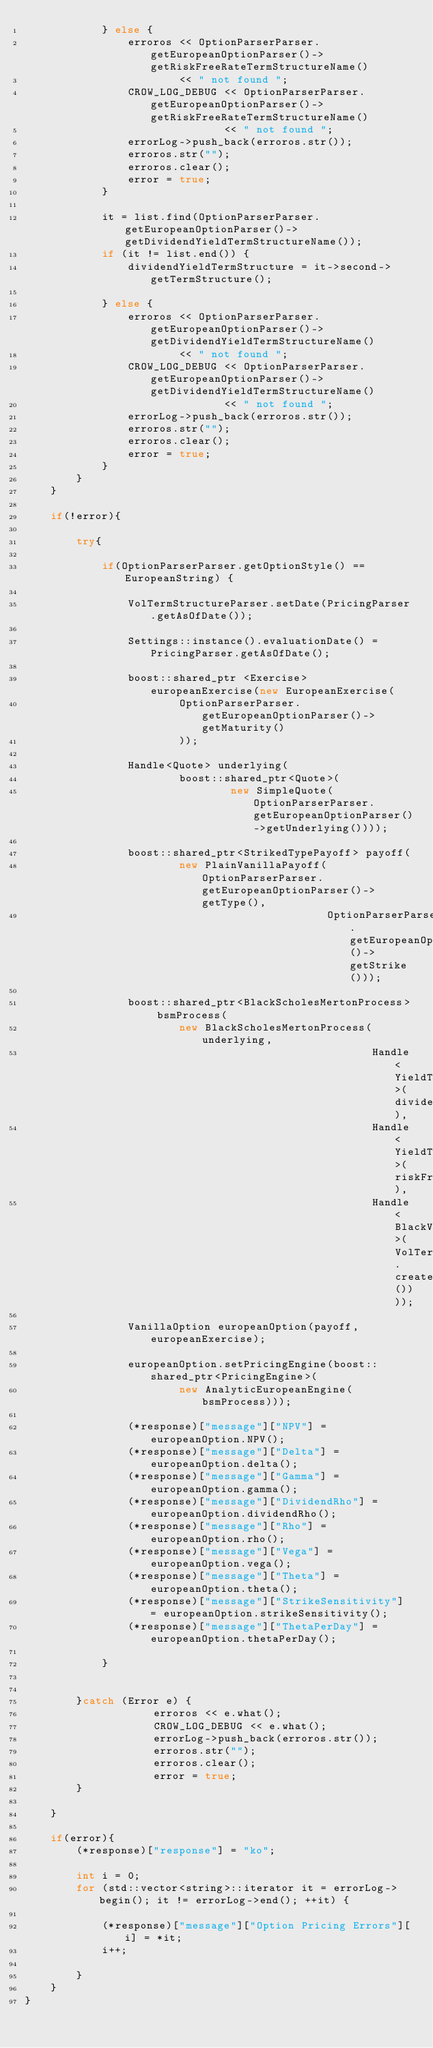Convert code to text. <code><loc_0><loc_0><loc_500><loc_500><_C++_>            } else {
                erroros << OptionParserParser.getEuropeanOptionParser()->getRiskFreeRateTermStructureName()
                        << " not found ";
                CROW_LOG_DEBUG << OptionParserParser.getEuropeanOptionParser()->getRiskFreeRateTermStructureName()
                               << " not found ";
                errorLog->push_back(erroros.str());
                erroros.str("");
                erroros.clear();
                error = true;
            }

            it = list.find(OptionParserParser.getEuropeanOptionParser()->getDividendYieldTermStructureName());
            if (it != list.end()) {
                dividendYieldTermStructure = it->second->getTermStructure();

            } else {
                erroros << OptionParserParser.getEuropeanOptionParser()->getDividendYieldTermStructureName()
                        << " not found ";
                CROW_LOG_DEBUG << OptionParserParser.getEuropeanOptionParser()->getDividendYieldTermStructureName()
                               << " not found ";
                errorLog->push_back(erroros.str());
                erroros.str("");
                erroros.clear();
                error = true;
            }
        }
    }

    if(!error){

        try{

            if(OptionParserParser.getOptionStyle() == EuropeanString) {

                VolTermStructureParser.setDate(PricingParser.getAsOfDate());

                Settings::instance().evaluationDate() = PricingParser.getAsOfDate();

                boost::shared_ptr <Exercise> europeanExercise(new EuropeanExercise(
                        OptionParserParser.getEuropeanOptionParser()->getMaturity()
                        ));

                Handle<Quote> underlying(
                        boost::shared_ptr<Quote>(
                                new SimpleQuote(OptionParserParser.getEuropeanOptionParser()->getUnderlying())));

                boost::shared_ptr<StrikedTypePayoff> payoff(
                        new PlainVanillaPayoff(OptionParserParser.getEuropeanOptionParser()->getType(),
                                               OptionParserParser.getEuropeanOptionParser()->getStrike()));

                boost::shared_ptr<BlackScholesMertonProcess> bsmProcess(
                        new BlackScholesMertonProcess(underlying,
                                                      Handle<YieldTermStructure>(dividendYieldTermStructure),
                                                      Handle<YieldTermStructure>(riskFreeRateTermStructure),
                                                      Handle<BlackVolTermStructure>(VolTermStructureParser.createVolTermStructure())));

                VanillaOption europeanOption(payoff, europeanExercise);

                europeanOption.setPricingEngine(boost::shared_ptr<PricingEngine>(
                        new AnalyticEuropeanEngine(bsmProcess)));

                (*response)["message"]["NPV"] = europeanOption.NPV();
                (*response)["message"]["Delta"] = europeanOption.delta();
                (*response)["message"]["Gamma"] = europeanOption.gamma();
                (*response)["message"]["DividendRho"] = europeanOption.dividendRho();
                (*response)["message"]["Rho"] = europeanOption.rho();
                (*response)["message"]["Vega"] = europeanOption.vega();
                (*response)["message"]["Theta"] = europeanOption.theta();
                (*response)["message"]["StrikeSensitivity"] = europeanOption.strikeSensitivity();
                (*response)["message"]["ThetaPerDay"] = europeanOption.thetaPerDay();

            }


        }catch (Error e) {
                    erroros << e.what();
                    CROW_LOG_DEBUG << e.what();
                    errorLog->push_back(erroros.str());
                    erroros.str("");
                    erroros.clear();
                    error = true;
        }

    }

    if(error){
        (*response)["response"] = "ko";

        int i = 0;
        for (std::vector<string>::iterator it = errorLog->begin(); it != errorLog->end(); ++it) {

            (*response)["message"]["Option Pricing Errors"][i] = *it;
            i++;

        }
    }
}</code> 